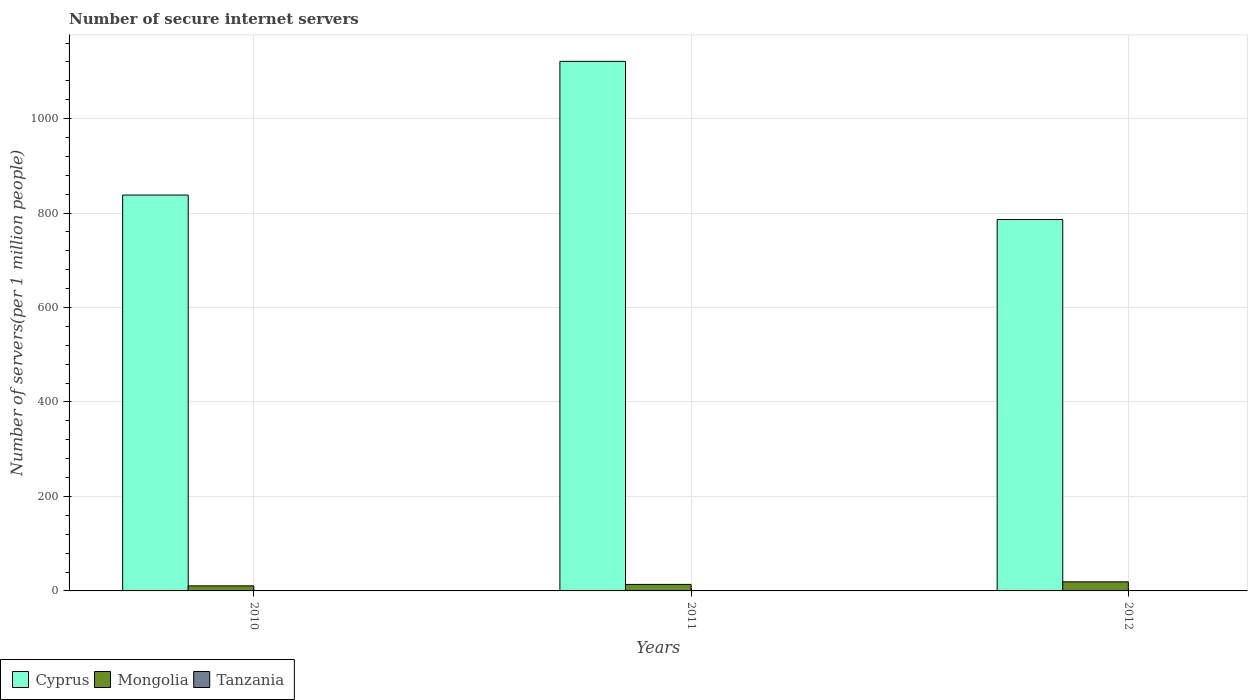How many groups of bars are there?
Provide a short and direct response. 3. How many bars are there on the 1st tick from the right?
Ensure brevity in your answer.  3. What is the number of secure internet servers in Cyprus in 2011?
Keep it short and to the point. 1121.22. Across all years, what is the maximum number of secure internet servers in Mongolia?
Ensure brevity in your answer.  19.23. Across all years, what is the minimum number of secure internet servers in Tanzania?
Offer a terse response. 0.39. In which year was the number of secure internet servers in Mongolia maximum?
Your answer should be compact. 2012. In which year was the number of secure internet servers in Cyprus minimum?
Keep it short and to the point. 2012. What is the total number of secure internet servers in Cyprus in the graph?
Offer a terse response. 2745.64. What is the difference between the number of secure internet servers in Tanzania in 2010 and that in 2011?
Keep it short and to the point. -0.09. What is the difference between the number of secure internet servers in Cyprus in 2011 and the number of secure internet servers in Tanzania in 2010?
Ensure brevity in your answer.  1120.82. What is the average number of secure internet servers in Cyprus per year?
Make the answer very short. 915.21. In the year 2012, what is the difference between the number of secure internet servers in Tanzania and number of secure internet servers in Cyprus?
Offer a terse response. -785.59. What is the ratio of the number of secure internet servers in Cyprus in 2011 to that in 2012?
Keep it short and to the point. 1.43. Is the number of secure internet servers in Tanzania in 2011 less than that in 2012?
Give a very brief answer. Yes. Is the difference between the number of secure internet servers in Tanzania in 2010 and 2012 greater than the difference between the number of secure internet servers in Cyprus in 2010 and 2012?
Give a very brief answer. No. What is the difference between the highest and the second highest number of secure internet servers in Mongolia?
Keep it short and to the point. 5.46. What is the difference between the highest and the lowest number of secure internet servers in Cyprus?
Give a very brief answer. 334.89. In how many years, is the number of secure internet servers in Tanzania greater than the average number of secure internet servers in Tanzania taken over all years?
Keep it short and to the point. 1. Is the sum of the number of secure internet servers in Cyprus in 2010 and 2012 greater than the maximum number of secure internet servers in Tanzania across all years?
Offer a very short reply. Yes. What does the 3rd bar from the left in 2010 represents?
Ensure brevity in your answer.  Tanzania. What does the 1st bar from the right in 2011 represents?
Provide a short and direct response. Tanzania. How many bars are there?
Provide a succinct answer. 9. What is the difference between two consecutive major ticks on the Y-axis?
Offer a terse response. 200. How many legend labels are there?
Your answer should be compact. 3. How are the legend labels stacked?
Your answer should be compact. Horizontal. What is the title of the graph?
Your answer should be compact. Number of secure internet servers. Does "Brunei Darussalam" appear as one of the legend labels in the graph?
Offer a very short reply. No. What is the label or title of the Y-axis?
Your answer should be very brief. Number of servers(per 1 million people). What is the Number of servers(per 1 million people) in Cyprus in 2010?
Offer a terse response. 838.1. What is the Number of servers(per 1 million people) in Mongolia in 2010?
Provide a short and direct response. 10.69. What is the Number of servers(per 1 million people) of Tanzania in 2010?
Your answer should be very brief. 0.39. What is the Number of servers(per 1 million people) of Cyprus in 2011?
Your response must be concise. 1121.22. What is the Number of servers(per 1 million people) in Mongolia in 2011?
Provide a succinct answer. 13.77. What is the Number of servers(per 1 million people) in Tanzania in 2011?
Give a very brief answer. 0.49. What is the Number of servers(per 1 million people) of Cyprus in 2012?
Give a very brief answer. 786.33. What is the Number of servers(per 1 million people) of Mongolia in 2012?
Provide a succinct answer. 19.23. What is the Number of servers(per 1 million people) in Tanzania in 2012?
Provide a short and direct response. 0.74. Across all years, what is the maximum Number of servers(per 1 million people) of Cyprus?
Make the answer very short. 1121.22. Across all years, what is the maximum Number of servers(per 1 million people) of Mongolia?
Give a very brief answer. 19.23. Across all years, what is the maximum Number of servers(per 1 million people) of Tanzania?
Provide a short and direct response. 0.74. Across all years, what is the minimum Number of servers(per 1 million people) of Cyprus?
Your response must be concise. 786.33. Across all years, what is the minimum Number of servers(per 1 million people) of Mongolia?
Give a very brief answer. 10.69. Across all years, what is the minimum Number of servers(per 1 million people) of Tanzania?
Your response must be concise. 0.39. What is the total Number of servers(per 1 million people) in Cyprus in the graph?
Offer a very short reply. 2745.64. What is the total Number of servers(per 1 million people) in Mongolia in the graph?
Make the answer very short. 43.69. What is the total Number of servers(per 1 million people) in Tanzania in the graph?
Ensure brevity in your answer.  1.62. What is the difference between the Number of servers(per 1 million people) in Cyprus in 2010 and that in 2011?
Keep it short and to the point. -283.12. What is the difference between the Number of servers(per 1 million people) of Mongolia in 2010 and that in 2011?
Ensure brevity in your answer.  -3.08. What is the difference between the Number of servers(per 1 million people) in Tanzania in 2010 and that in 2011?
Your response must be concise. -0.09. What is the difference between the Number of servers(per 1 million people) of Cyprus in 2010 and that in 2012?
Give a very brief answer. 51.78. What is the difference between the Number of servers(per 1 million people) of Mongolia in 2010 and that in 2012?
Keep it short and to the point. -8.54. What is the difference between the Number of servers(per 1 million people) of Tanzania in 2010 and that in 2012?
Offer a terse response. -0.35. What is the difference between the Number of servers(per 1 million people) of Cyprus in 2011 and that in 2012?
Your response must be concise. 334.89. What is the difference between the Number of servers(per 1 million people) of Mongolia in 2011 and that in 2012?
Your answer should be compact. -5.46. What is the difference between the Number of servers(per 1 million people) in Tanzania in 2011 and that in 2012?
Offer a terse response. -0.25. What is the difference between the Number of servers(per 1 million people) in Cyprus in 2010 and the Number of servers(per 1 million people) in Mongolia in 2011?
Ensure brevity in your answer.  824.33. What is the difference between the Number of servers(per 1 million people) in Cyprus in 2010 and the Number of servers(per 1 million people) in Tanzania in 2011?
Give a very brief answer. 837.61. What is the difference between the Number of servers(per 1 million people) in Mongolia in 2010 and the Number of servers(per 1 million people) in Tanzania in 2011?
Provide a short and direct response. 10.2. What is the difference between the Number of servers(per 1 million people) in Cyprus in 2010 and the Number of servers(per 1 million people) in Mongolia in 2012?
Ensure brevity in your answer.  818.87. What is the difference between the Number of servers(per 1 million people) in Cyprus in 2010 and the Number of servers(per 1 million people) in Tanzania in 2012?
Offer a terse response. 837.36. What is the difference between the Number of servers(per 1 million people) in Mongolia in 2010 and the Number of servers(per 1 million people) in Tanzania in 2012?
Provide a succinct answer. 9.95. What is the difference between the Number of servers(per 1 million people) of Cyprus in 2011 and the Number of servers(per 1 million people) of Mongolia in 2012?
Offer a very short reply. 1101.99. What is the difference between the Number of servers(per 1 million people) of Cyprus in 2011 and the Number of servers(per 1 million people) of Tanzania in 2012?
Offer a very short reply. 1120.48. What is the difference between the Number of servers(per 1 million people) of Mongolia in 2011 and the Number of servers(per 1 million people) of Tanzania in 2012?
Offer a terse response. 13.03. What is the average Number of servers(per 1 million people) of Cyprus per year?
Make the answer very short. 915.21. What is the average Number of servers(per 1 million people) of Mongolia per year?
Keep it short and to the point. 14.56. What is the average Number of servers(per 1 million people) in Tanzania per year?
Give a very brief answer. 0.54. In the year 2010, what is the difference between the Number of servers(per 1 million people) of Cyprus and Number of servers(per 1 million people) of Mongolia?
Ensure brevity in your answer.  827.41. In the year 2010, what is the difference between the Number of servers(per 1 million people) of Cyprus and Number of servers(per 1 million people) of Tanzania?
Make the answer very short. 837.71. In the year 2010, what is the difference between the Number of servers(per 1 million people) of Mongolia and Number of servers(per 1 million people) of Tanzania?
Provide a succinct answer. 10.3. In the year 2011, what is the difference between the Number of servers(per 1 million people) in Cyprus and Number of servers(per 1 million people) in Mongolia?
Provide a short and direct response. 1107.44. In the year 2011, what is the difference between the Number of servers(per 1 million people) in Cyprus and Number of servers(per 1 million people) in Tanzania?
Your response must be concise. 1120.73. In the year 2011, what is the difference between the Number of servers(per 1 million people) of Mongolia and Number of servers(per 1 million people) of Tanzania?
Your answer should be compact. 13.28. In the year 2012, what is the difference between the Number of servers(per 1 million people) of Cyprus and Number of servers(per 1 million people) of Mongolia?
Keep it short and to the point. 767.1. In the year 2012, what is the difference between the Number of servers(per 1 million people) of Cyprus and Number of servers(per 1 million people) of Tanzania?
Provide a succinct answer. 785.59. In the year 2012, what is the difference between the Number of servers(per 1 million people) in Mongolia and Number of servers(per 1 million people) in Tanzania?
Offer a very short reply. 18.49. What is the ratio of the Number of servers(per 1 million people) of Cyprus in 2010 to that in 2011?
Offer a very short reply. 0.75. What is the ratio of the Number of servers(per 1 million people) of Mongolia in 2010 to that in 2011?
Your response must be concise. 0.78. What is the ratio of the Number of servers(per 1 million people) in Tanzania in 2010 to that in 2011?
Keep it short and to the point. 0.81. What is the ratio of the Number of servers(per 1 million people) of Cyprus in 2010 to that in 2012?
Provide a short and direct response. 1.07. What is the ratio of the Number of servers(per 1 million people) of Mongolia in 2010 to that in 2012?
Offer a terse response. 0.56. What is the ratio of the Number of servers(per 1 million people) in Tanzania in 2010 to that in 2012?
Ensure brevity in your answer.  0.53. What is the ratio of the Number of servers(per 1 million people) of Cyprus in 2011 to that in 2012?
Your answer should be very brief. 1.43. What is the ratio of the Number of servers(per 1 million people) of Mongolia in 2011 to that in 2012?
Make the answer very short. 0.72. What is the ratio of the Number of servers(per 1 million people) of Tanzania in 2011 to that in 2012?
Provide a short and direct response. 0.66. What is the difference between the highest and the second highest Number of servers(per 1 million people) of Cyprus?
Make the answer very short. 283.12. What is the difference between the highest and the second highest Number of servers(per 1 million people) of Mongolia?
Make the answer very short. 5.46. What is the difference between the highest and the second highest Number of servers(per 1 million people) of Tanzania?
Provide a short and direct response. 0.25. What is the difference between the highest and the lowest Number of servers(per 1 million people) in Cyprus?
Your response must be concise. 334.89. What is the difference between the highest and the lowest Number of servers(per 1 million people) of Mongolia?
Your answer should be very brief. 8.54. What is the difference between the highest and the lowest Number of servers(per 1 million people) in Tanzania?
Provide a succinct answer. 0.35. 